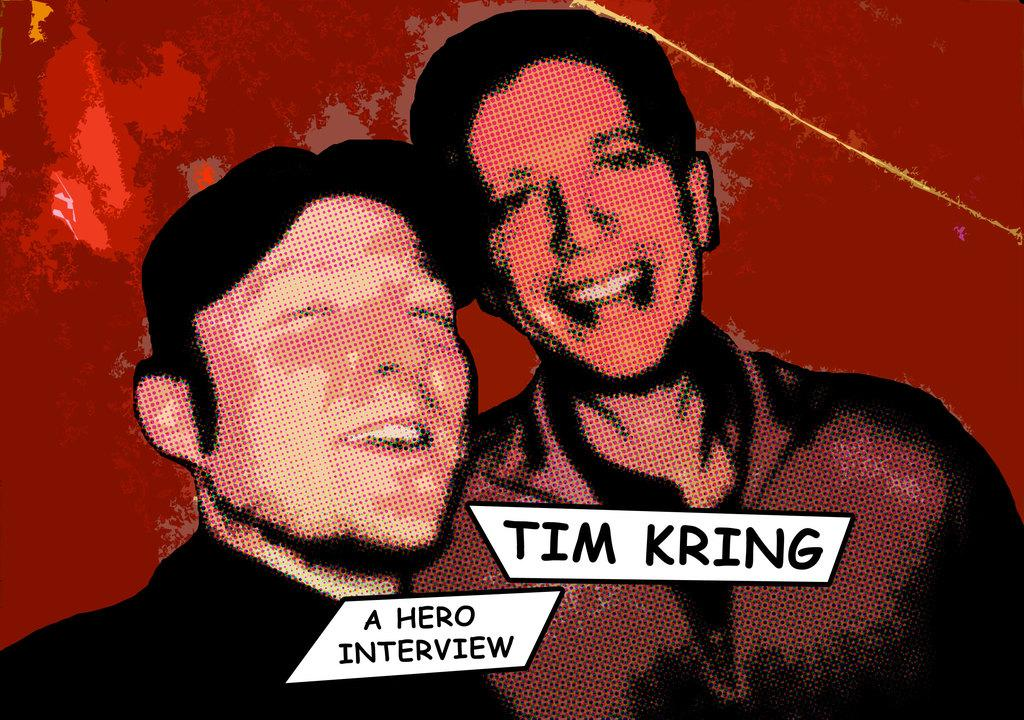What is the color of the object in the image? The object in the image is red. What type of object is it? The red object appears to be a poster. What can be seen on the poster? There are pictures of two persons on the poster. Is there any text on the poster? Yes, there is text on the poster. What is the name of the person washing their hands in the image? There is no person washing their hands in the image; it features a red poster with pictures of two persons and text. 